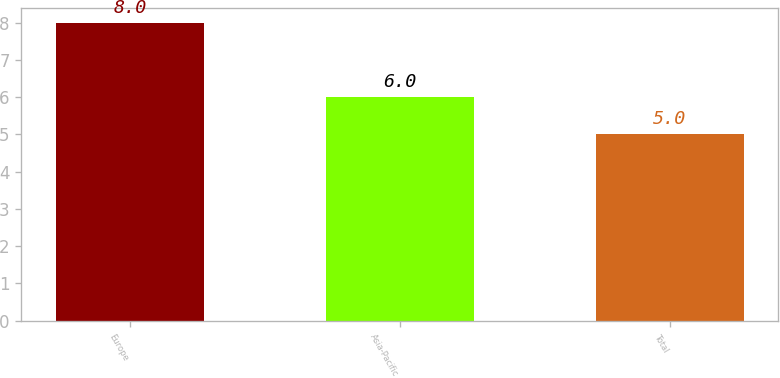Convert chart. <chart><loc_0><loc_0><loc_500><loc_500><bar_chart><fcel>Europe<fcel>Asia-Pacific<fcel>Total<nl><fcel>8<fcel>6<fcel>5<nl></chart> 